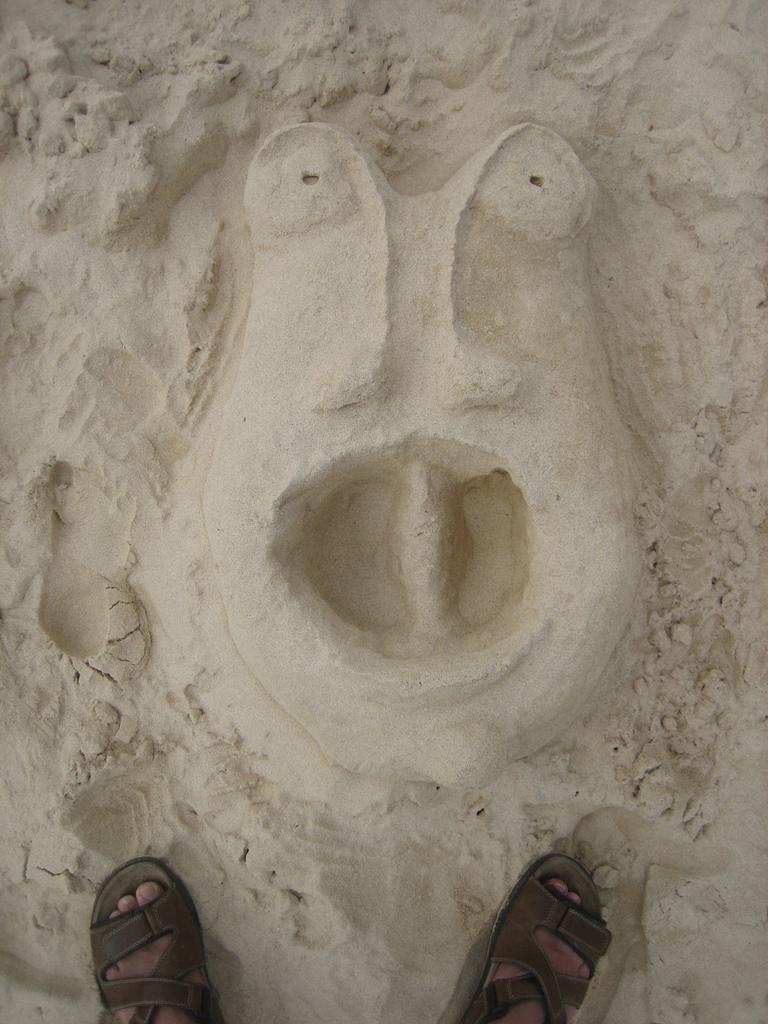What can be seen at the bottom of the image? There are legs of persons visible at the bottom of the image. What is happening in the image? There is a depiction of a person on the sand in the image. What type of skirt is being worn by the person in the image? There is no skirt visible in the image, as it depicts a person on the sand without any clothing details. 